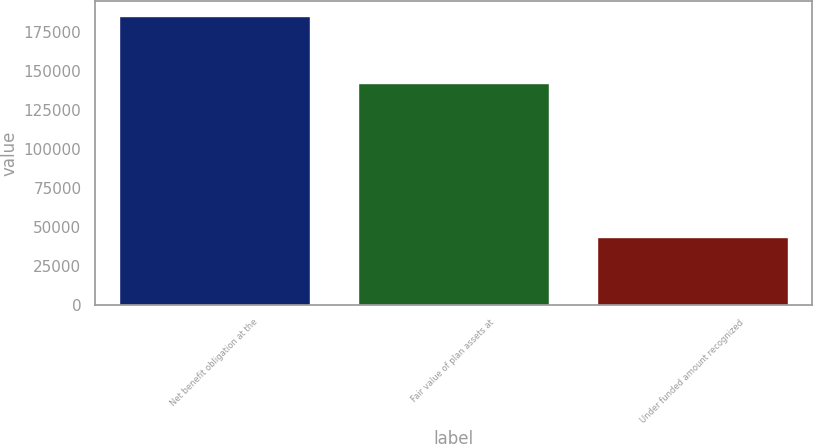Convert chart. <chart><loc_0><loc_0><loc_500><loc_500><bar_chart><fcel>Net benefit obligation at the<fcel>Fair value of plan assets at<fcel>Under funded amount recognized<nl><fcel>185664<fcel>142464<fcel>43200<nl></chart> 